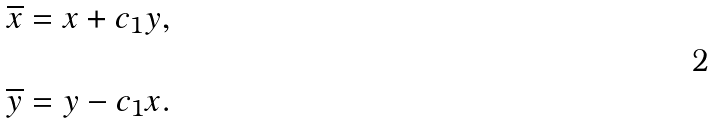Convert formula to latex. <formula><loc_0><loc_0><loc_500><loc_500>\overline { x } & = x + c _ { 1 } y , \\ & \\ \overline { y } & = y - c _ { 1 } x .</formula> 